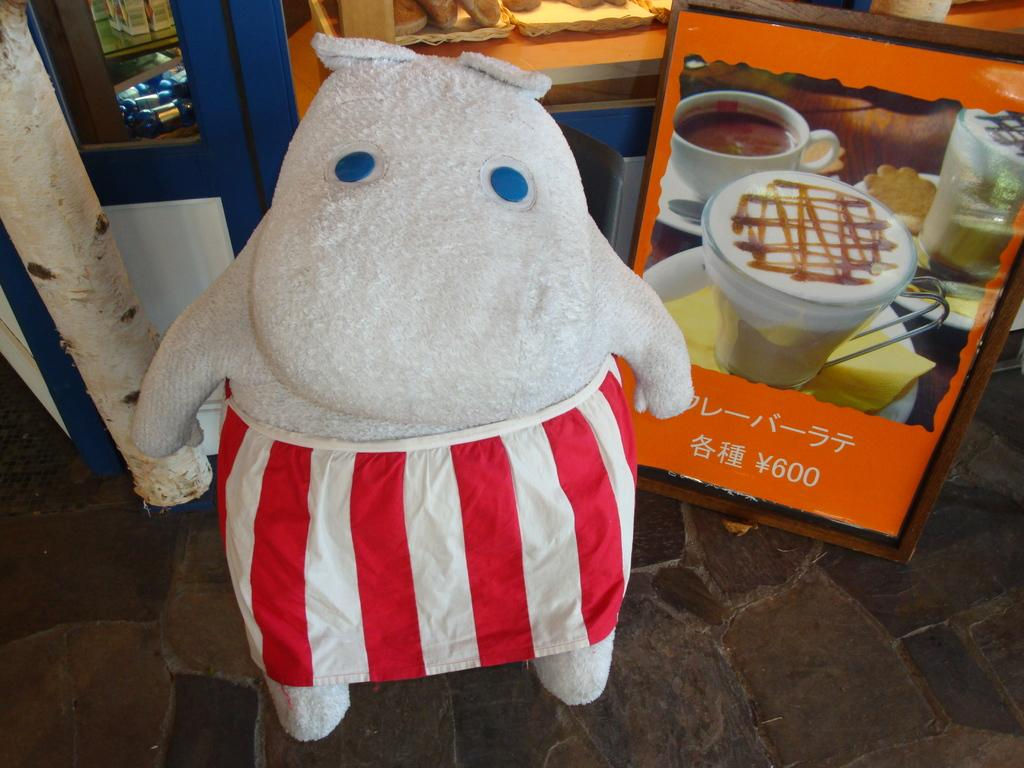What is on the ground in the image? There is a toy and a board on the ground in the image. What can be seen through the glass doors in the background? Objects are visible through the glass doors in the image. Can you describe the board on the ground? The facts provided do not give a detailed description of the board. What type of shoe is being used as a horn in the image? There is no shoe or horn present in the image. 